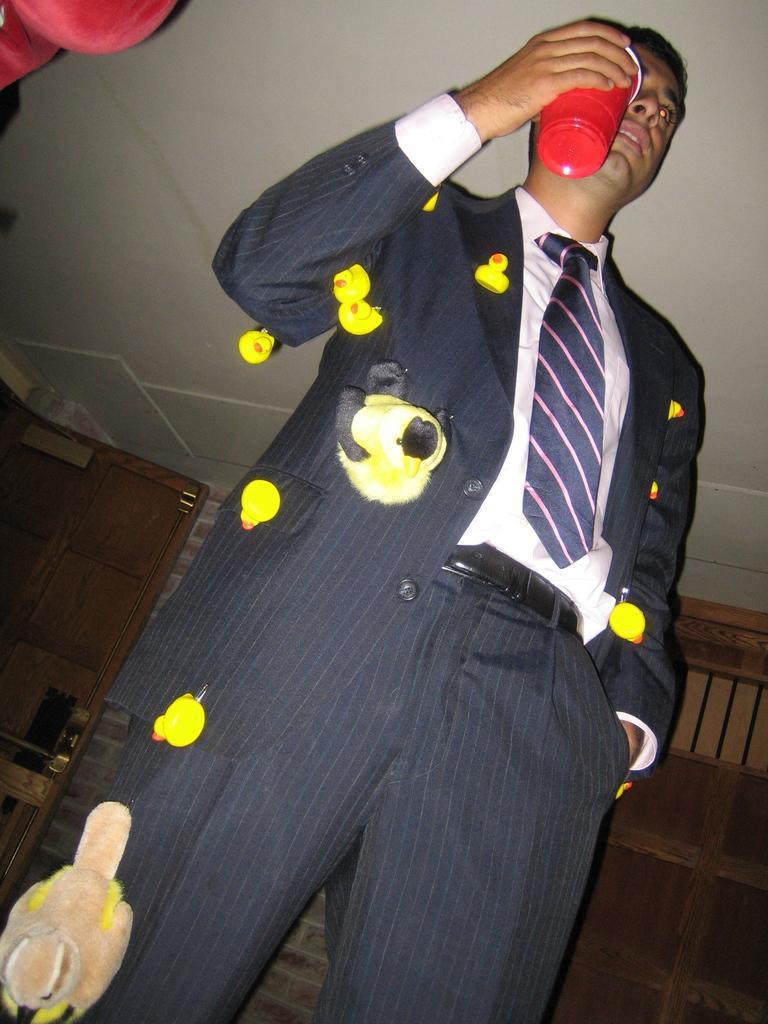How would you summarize this image in a sentence or two? In this image there is a man standing. He is holding a glass in his hand. There are duck toys attached to his dress. Behind him there is a wall. At the top there is the ceiling. 